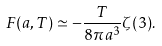Convert formula to latex. <formula><loc_0><loc_0><loc_500><loc_500>F ( a , T ) \simeq - \frac { T } { 8 \pi a ^ { 3 } } \zeta ( 3 ) .</formula> 